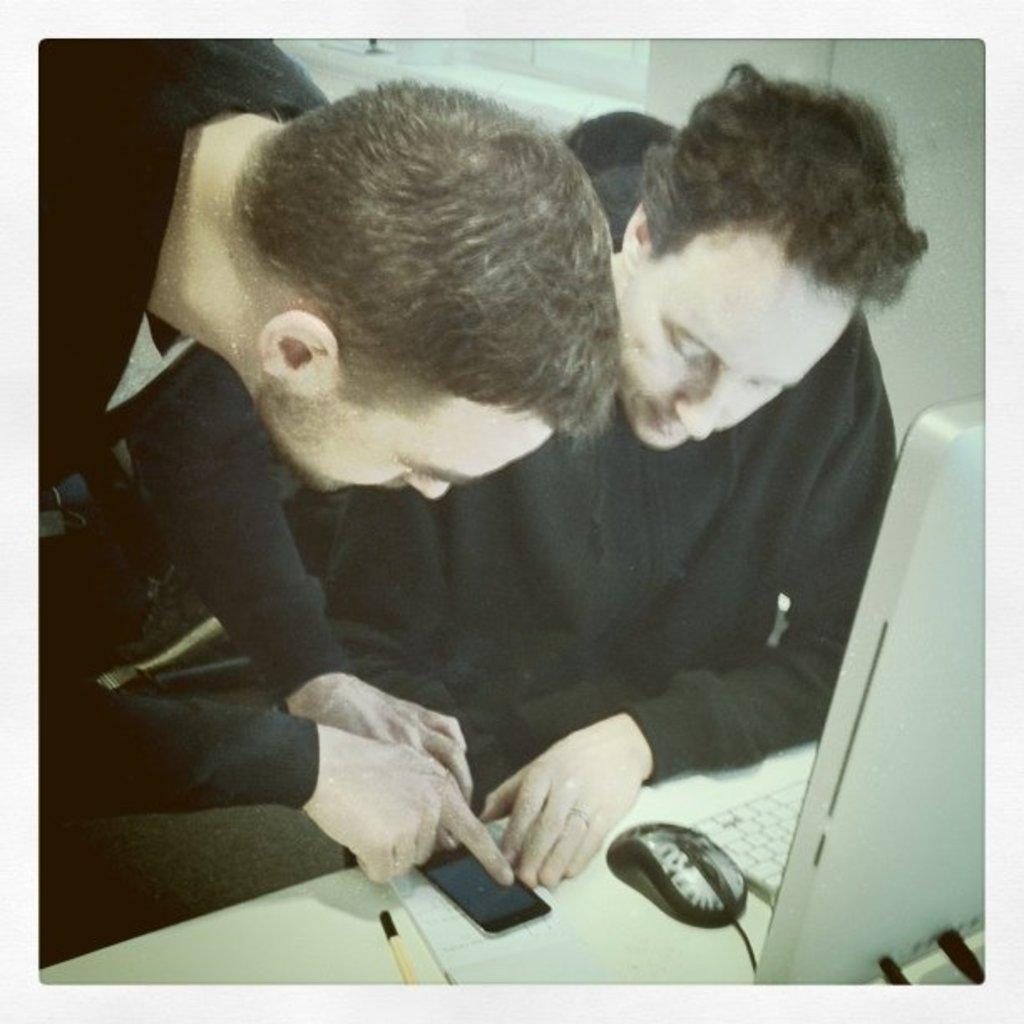How many people are in the image? There are two persons in the image. What are the two persons doing in the image? The two persons are operating a mobile phone. What other electronic device is present in the image? There is a computer in front of the two persons. Can you see any icicles hanging from the computer in the image? There are no icicles present in the image, as it is an indoor scene with no visible ice or cold temperatures. 